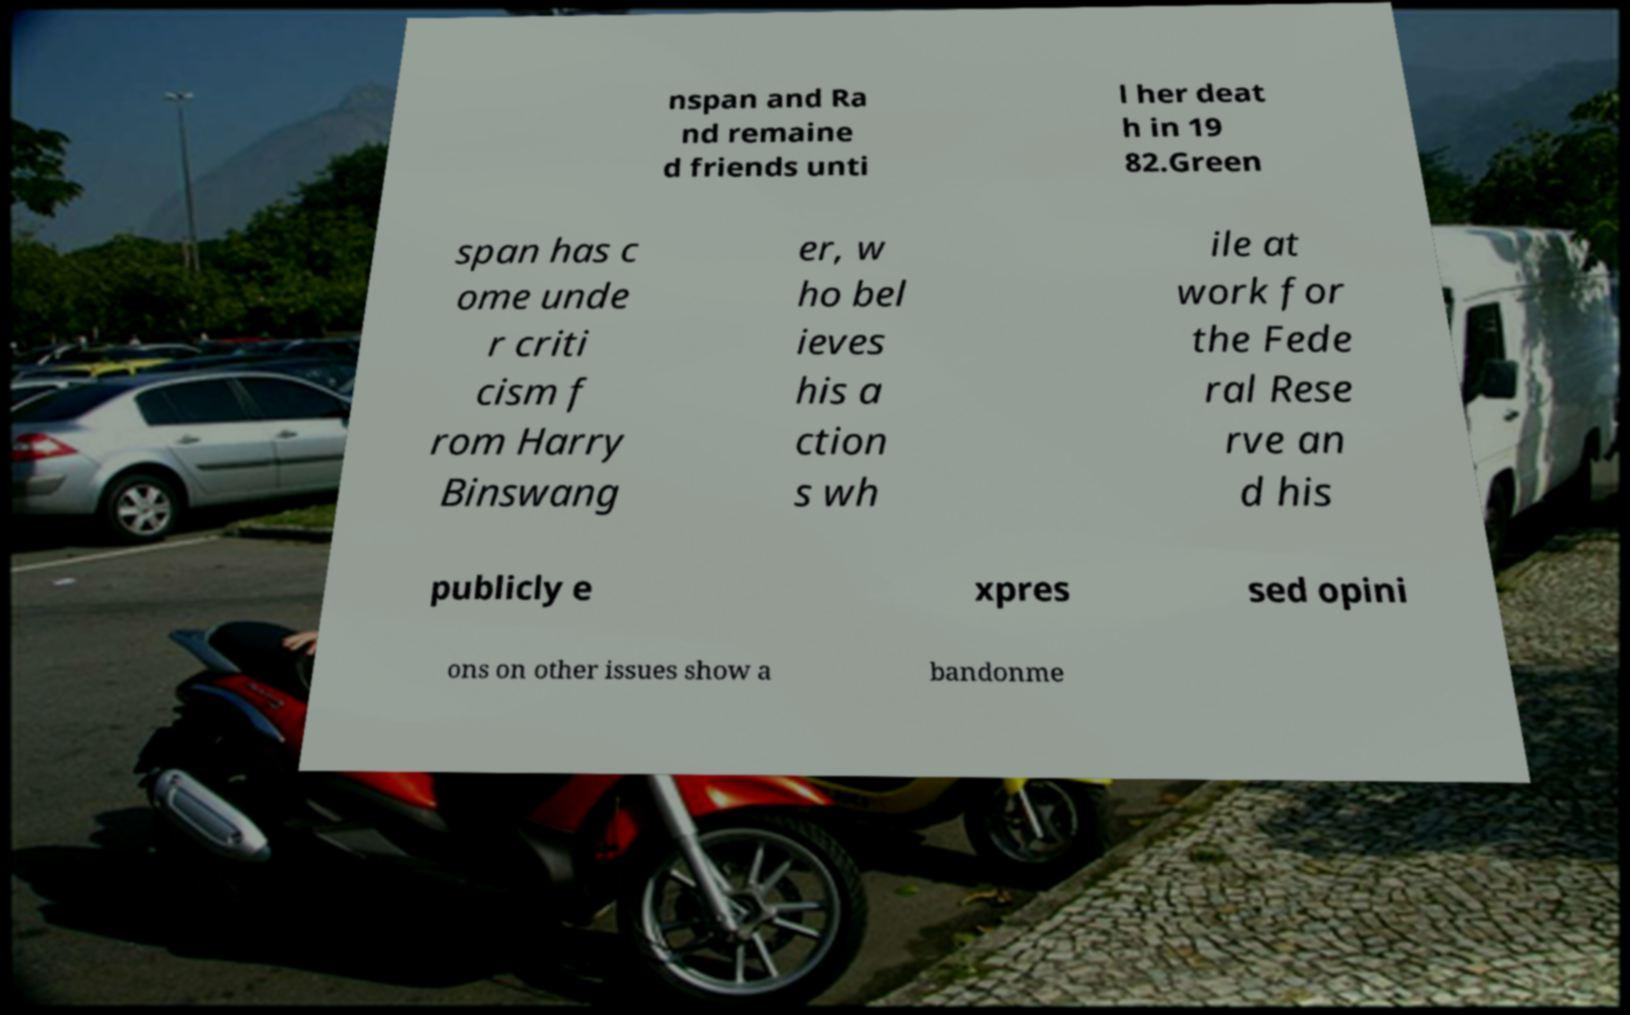What messages or text are displayed in this image? I need them in a readable, typed format. nspan and Ra nd remaine d friends unti l her deat h in 19 82.Green span has c ome unde r criti cism f rom Harry Binswang er, w ho bel ieves his a ction s wh ile at work for the Fede ral Rese rve an d his publicly e xpres sed opini ons on other issues show a bandonme 